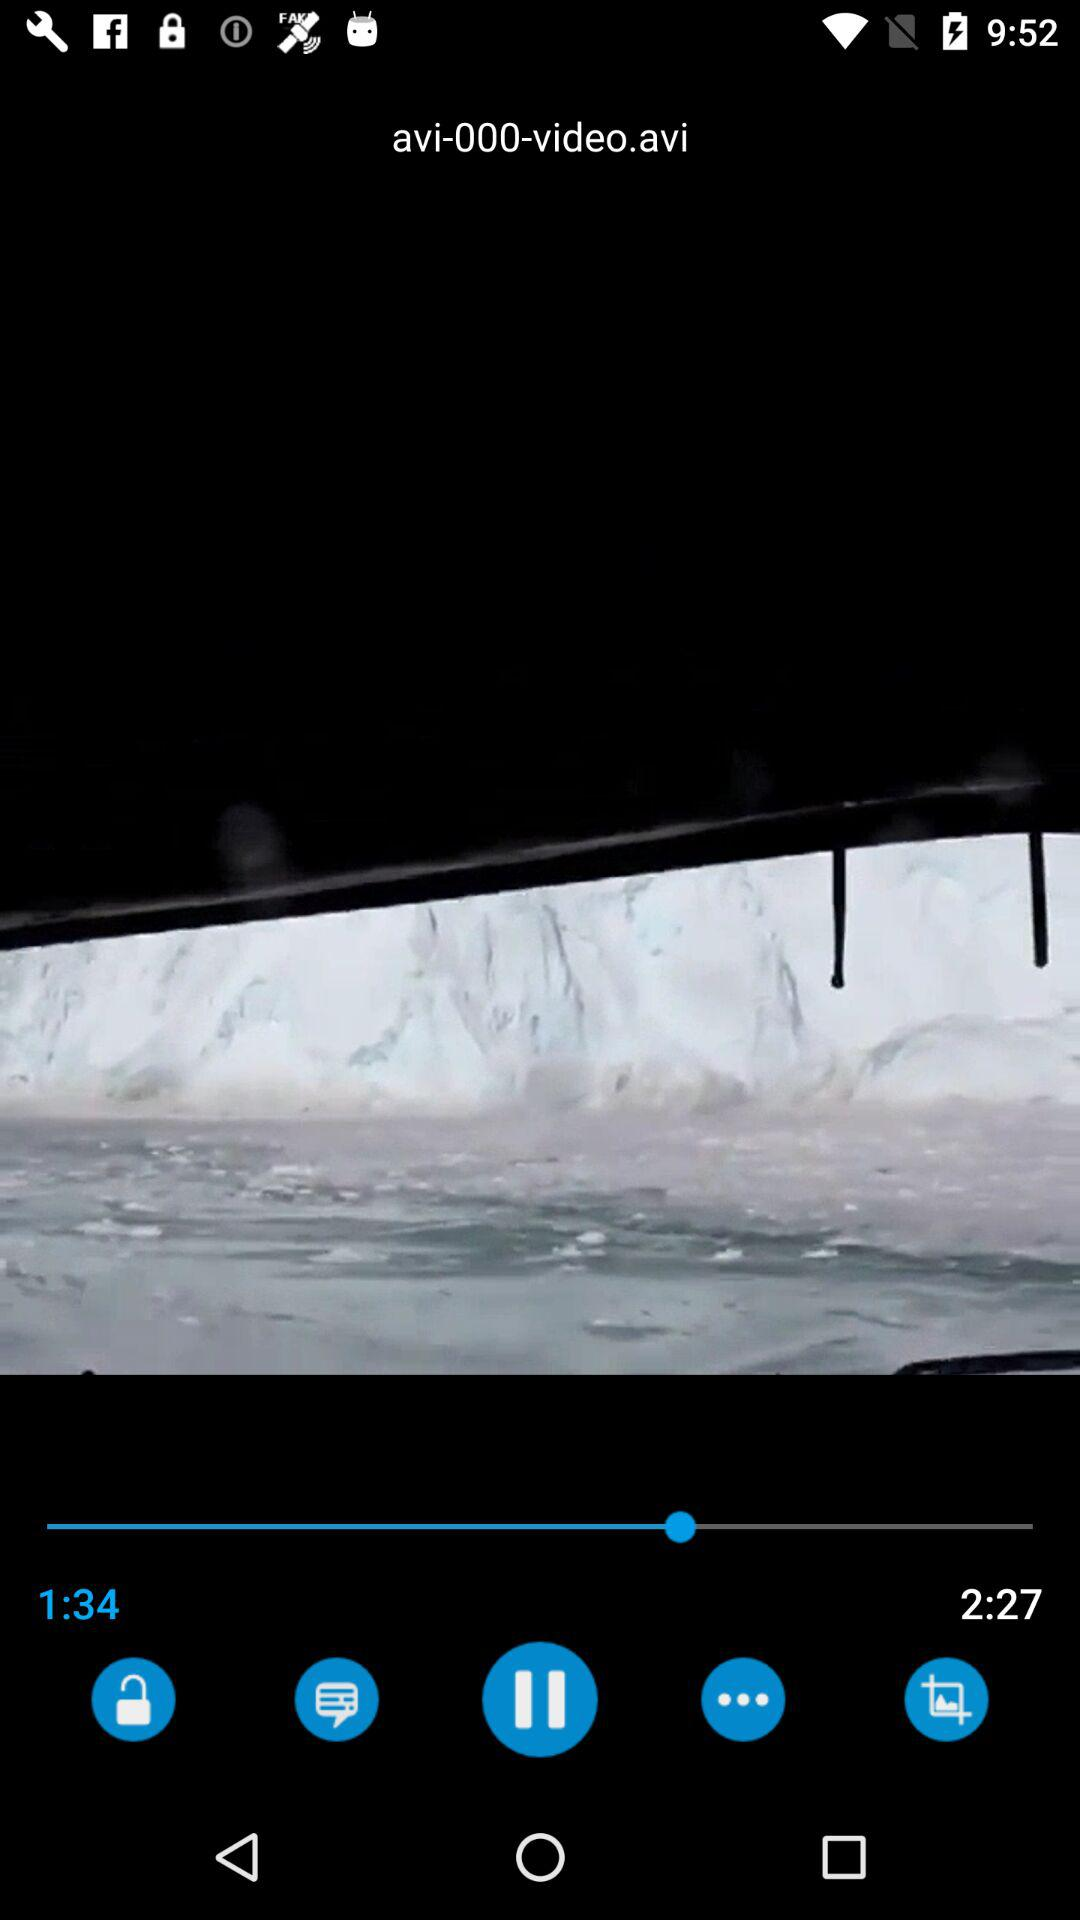What is the total length of the video? The total length of the video is 2 minutes and 27 seconds. 